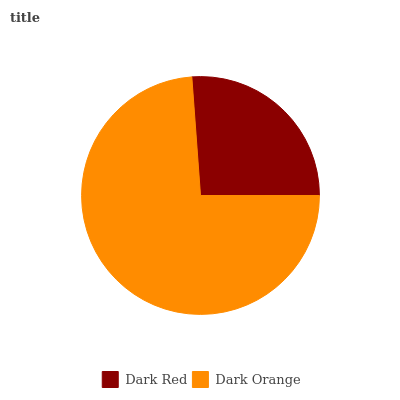Is Dark Red the minimum?
Answer yes or no. Yes. Is Dark Orange the maximum?
Answer yes or no. Yes. Is Dark Orange the minimum?
Answer yes or no. No. Is Dark Orange greater than Dark Red?
Answer yes or no. Yes. Is Dark Red less than Dark Orange?
Answer yes or no. Yes. Is Dark Red greater than Dark Orange?
Answer yes or no. No. Is Dark Orange less than Dark Red?
Answer yes or no. No. Is Dark Orange the high median?
Answer yes or no. Yes. Is Dark Red the low median?
Answer yes or no. Yes. Is Dark Red the high median?
Answer yes or no. No. Is Dark Orange the low median?
Answer yes or no. No. 